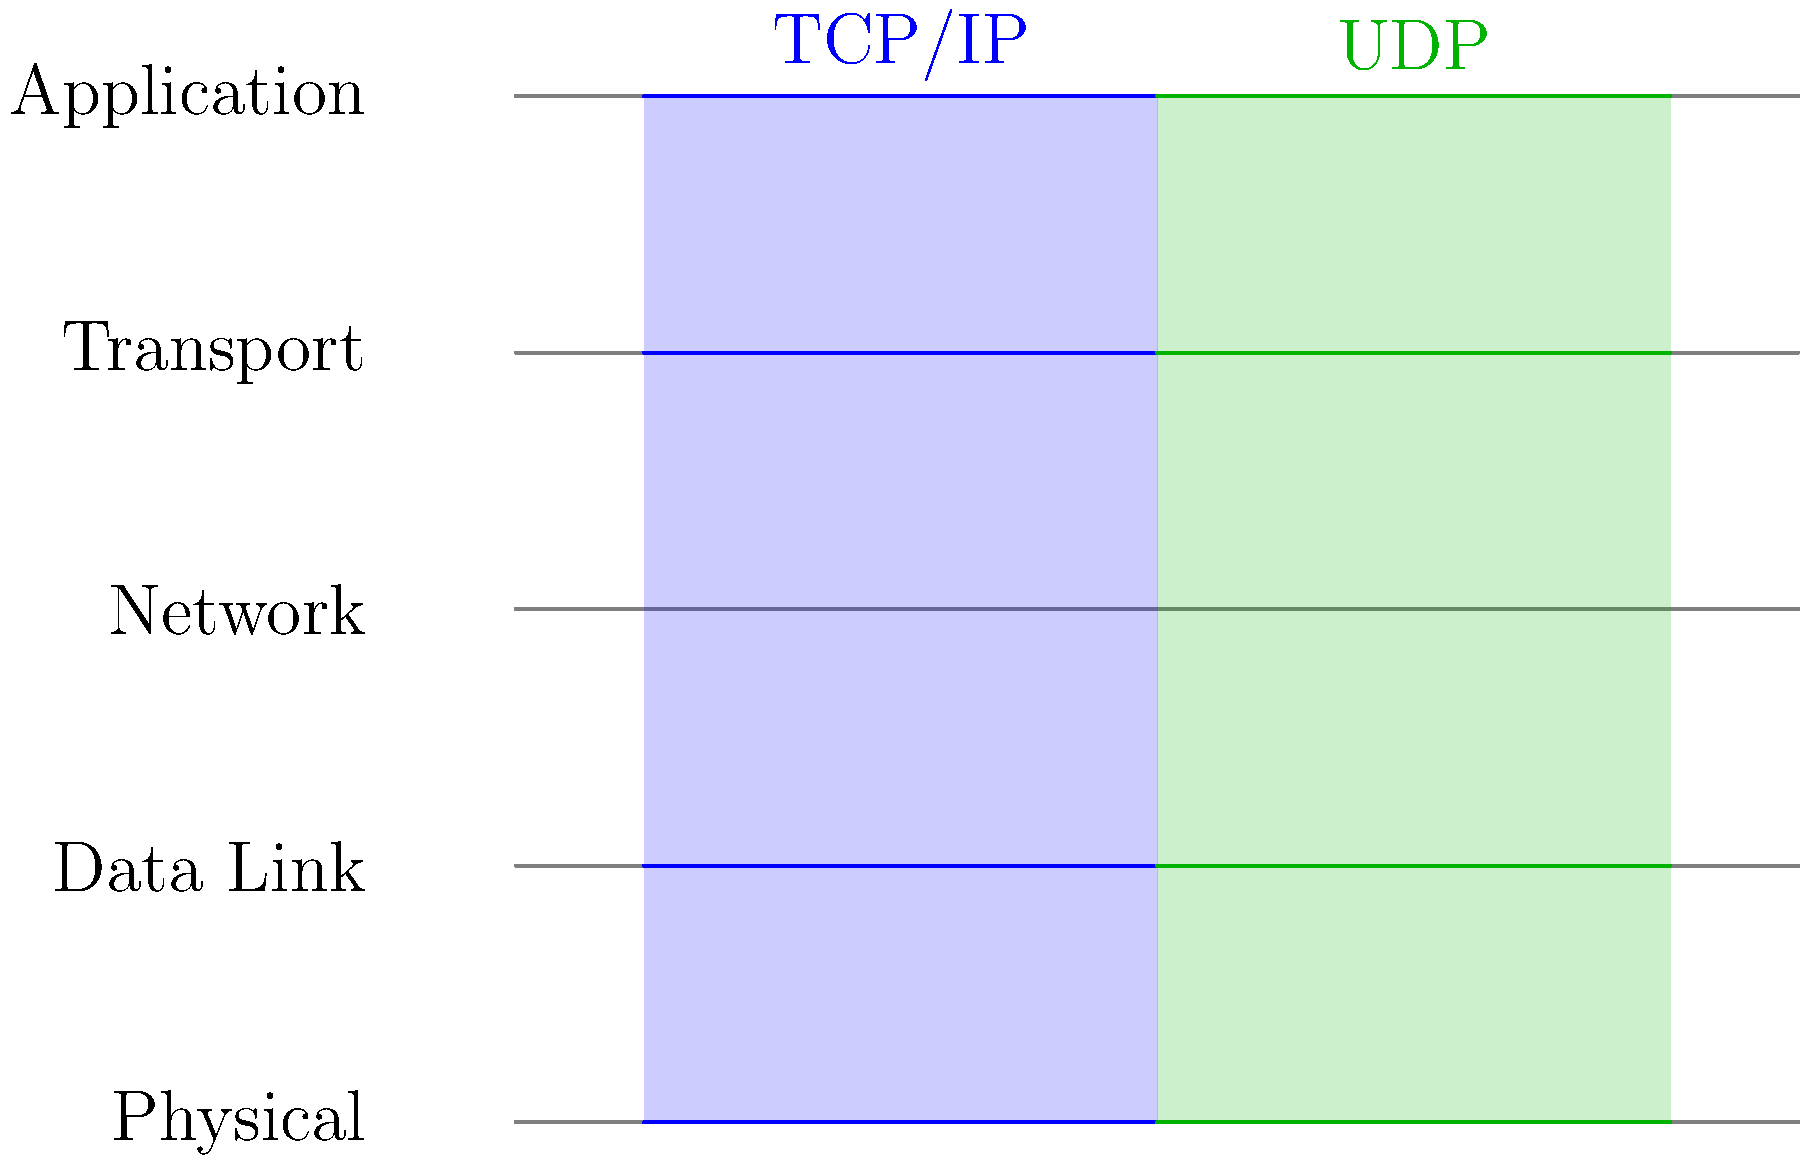Based on the layered diagram comparing TCP/IP and UDP packet structures, which protocol would be more suitable for a real-time application that can tolerate occasional packet loss but requires minimal latency? Explain your reasoning considering the differences in their transport layer implementations. To answer this question, we need to analyze the diagram and understand the key differences between TCP/IP and UDP, particularly at the transport layer:

1. TCP/IP (Transmission Control Protocol/Internet Protocol):
   - Occupies all layers from Physical to Application
   - Has a distinct Transport layer (layer 4)
   - Known for reliable, connection-oriented communication
   - Implements error checking, packet ordering, and flow control
   - Ensures all packets are delivered in the correct order

2. UDP (User Datagram Protocol):
   - Also spans all layers from Physical to Application
   - Has a thinner Transport layer compared to TCP
   - Provides a connectionless, unreliable communication
   - Does not implement error checking or packet ordering
   - Offers lower overhead and faster transmission

For a real-time application that can tolerate occasional packet loss but requires minimal latency:

1. Latency requirement: UDP has lower latency due to its simpler transport layer implementation. It doesn't wait for acknowledgments or retransmit lost packets.

2. Tolerance for packet loss: UDP's lack of guaranteed delivery aligns with the application's ability to tolerate occasional packet loss.

3. Real-time nature: Real-time applications often prioritize speed over perfect reliability. UDP's "fire-and-forget" approach is more suitable for such scenarios.

4. Minimal overhead: UDP's simpler structure results in smaller packet sizes and less processing overhead, which can be beneficial for real-time applications.

5. No connection establishment: UDP doesn't require a formal connection setup, allowing for faster initial data transmission.

Given these factors, UDP would be more suitable for a real-time application with the specified requirements. Its lower latency and ability to continue sending data without waiting for acknowledgments or retransmissions make it a better choice when some packet loss is acceptable in exchange for speed.
Answer: UDP, due to lower latency and tolerance for packet loss. 